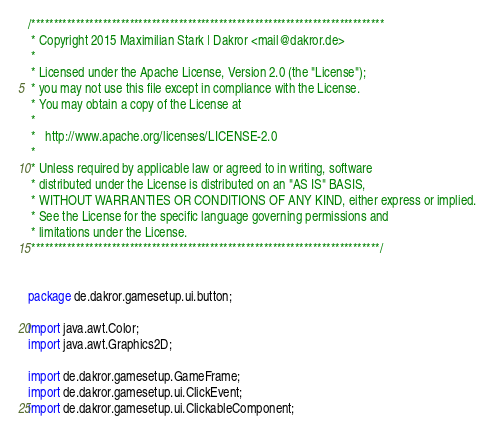Convert code to text. <code><loc_0><loc_0><loc_500><loc_500><_Java_>/*******************************************************************************
 * Copyright 2015 Maximilian Stark | Dakror <mail@dakror.de>
 * 
 * Licensed under the Apache License, Version 2.0 (the "License");
 * you may not use this file except in compliance with the License.
 * You may obtain a copy of the License at
 * 
 *   http://www.apache.org/licenses/LICENSE-2.0
 * 
 * Unless required by applicable law or agreed to in writing, software
 * distributed under the License is distributed on an "AS IS" BASIS,
 * WITHOUT WARRANTIES OR CONDITIONS OF ANY KIND, either express or implied.
 * See the License for the specific language governing permissions and
 * limitations under the License.
 ******************************************************************************/


package de.dakror.gamesetup.ui.button;

import java.awt.Color;
import java.awt.Graphics2D;

import de.dakror.gamesetup.GameFrame;
import de.dakror.gamesetup.ui.ClickEvent;
import de.dakror.gamesetup.ui.ClickableComponent;</code> 